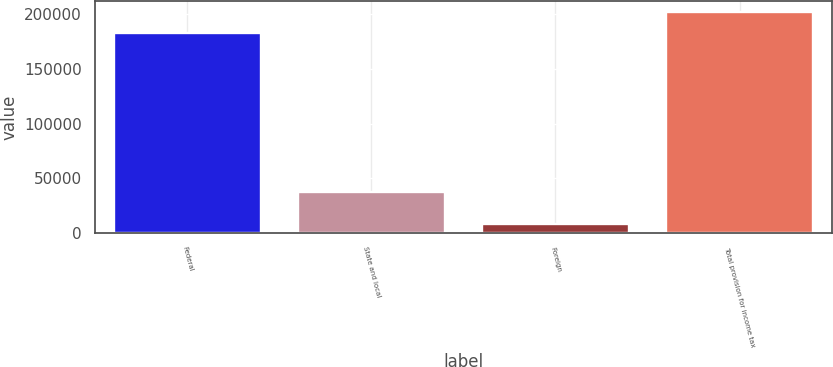Convert chart to OTSL. <chart><loc_0><loc_0><loc_500><loc_500><bar_chart><fcel>Federal<fcel>State and local<fcel>Foreign<fcel>Total provision for income tax<nl><fcel>182862<fcel>37491<fcel>8469<fcel>201718<nl></chart> 